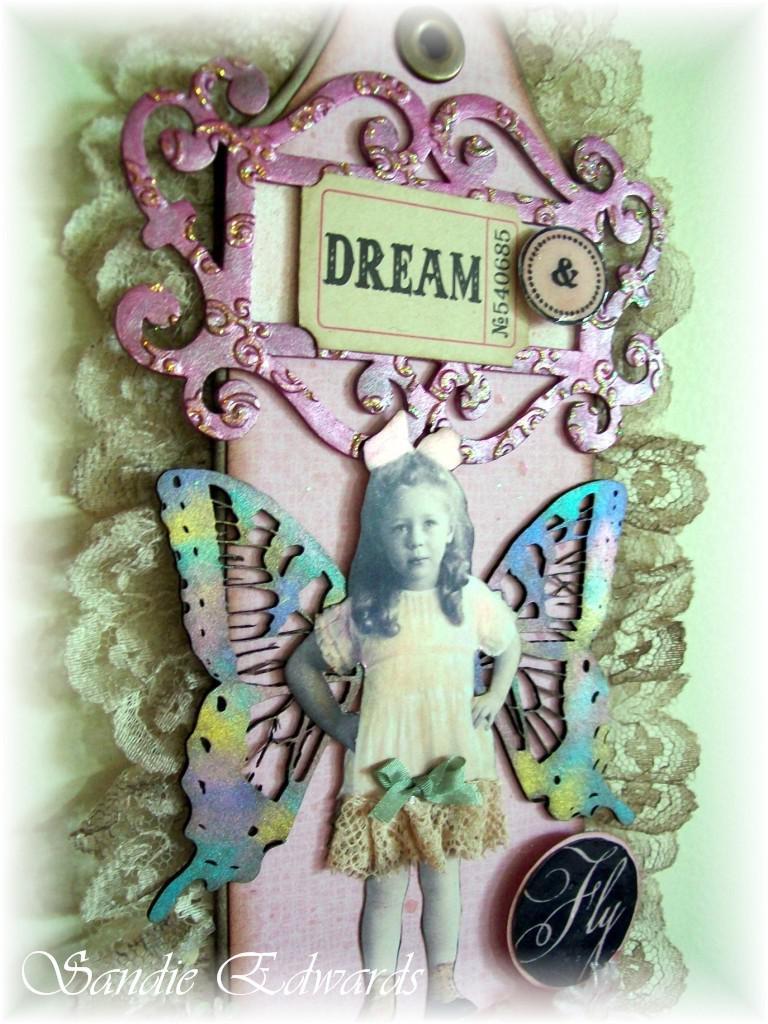What is the word on the ticket?
Ensure brevity in your answer.  Dream. Does it say "fly" on the button?
Your response must be concise. Yes. 